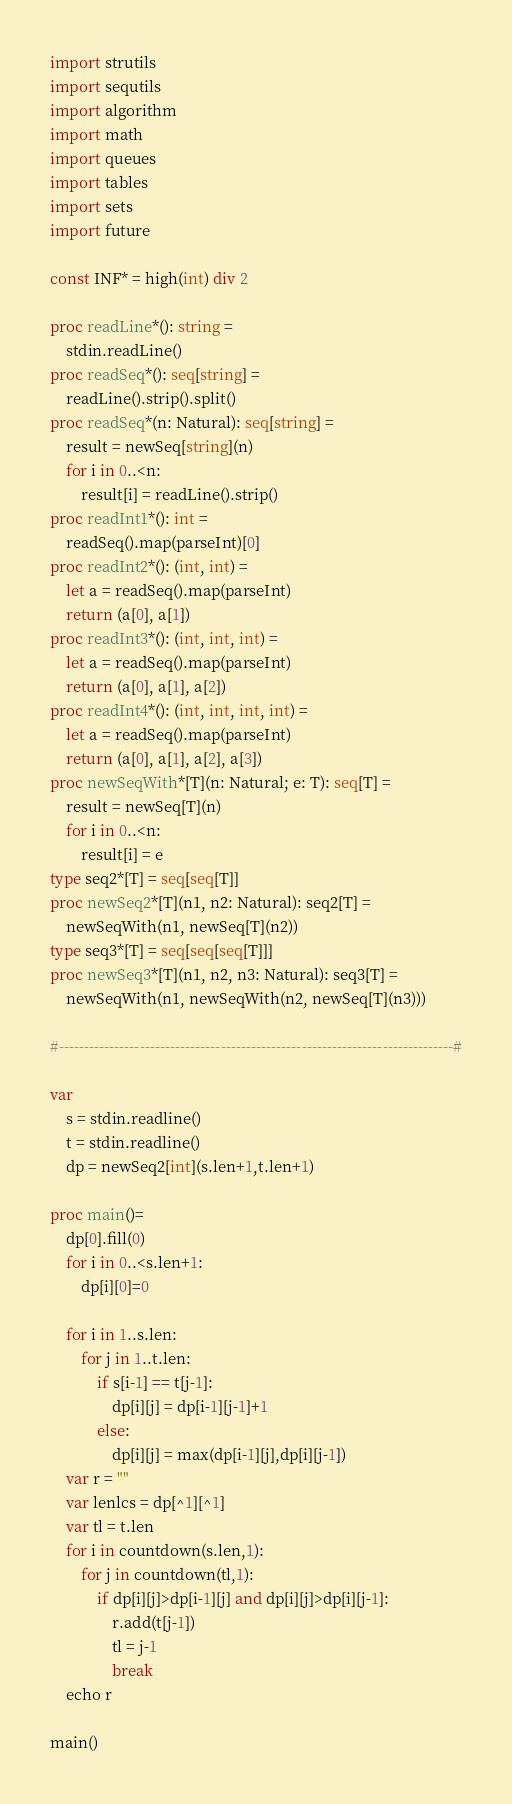<code> <loc_0><loc_0><loc_500><loc_500><_Nim_>import strutils
import sequtils
import algorithm
import math
import queues
import tables
import sets
import future
 
const INF* = high(int) div 2
 
proc readLine*(): string =
    stdin.readLine()
proc readSeq*(): seq[string] =
    readLine().strip().split()
proc readSeq*(n: Natural): seq[string] =
    result = newSeq[string](n)
    for i in 0..<n:
        result[i] = readLine().strip()
proc readInt1*(): int =
    readSeq().map(parseInt)[0]
proc readInt2*(): (int, int) =
    let a = readSeq().map(parseInt)
    return (a[0], a[1])
proc readInt3*(): (int, int, int) =
    let a = readSeq().map(parseInt)
    return (a[0], a[1], a[2])
proc readInt4*(): (int, int, int, int) =
    let a = readSeq().map(parseInt)
    return (a[0], a[1], a[2], a[3])
proc newSeqWith*[T](n: Natural; e: T): seq[T] =
    result = newSeq[T](n)
    for i in 0..<n:
        result[i] = e
type seq2*[T] = seq[seq[T]]
proc newSeq2*[T](n1, n2: Natural): seq2[T] =
    newSeqWith(n1, newSeq[T](n2))
type seq3*[T] = seq[seq[seq[T]]]
proc newSeq3*[T](n1, n2, n3: Natural): seq3[T] =
    newSeqWith(n1, newSeqWith(n2, newSeq[T](n3)))
 
#------------------------------------------------------------------------------#

var
    s = stdin.readline()
    t = stdin.readline()
    dp = newSeq2[int](s.len+1,t.len+1)

proc main()=
    dp[0].fill(0)
    for i in 0..<s.len+1:
        dp[i][0]=0

    for i in 1..s.len:
        for j in 1..t.len:
            if s[i-1] == t[j-1]:
                dp[i][j] = dp[i-1][j-1]+1
            else:
                dp[i][j] = max(dp[i-1][j],dp[i][j-1])
    var r = ""
    var lenlcs = dp[^1][^1]
    var tl = t.len
    for i in countdown(s.len,1):
        for j in countdown(tl,1):
            if dp[i][j]>dp[i-1][j] and dp[i][j]>dp[i][j-1]:
                r.add(t[j-1])
                tl = j-1
                break
    echo r

main()
</code> 